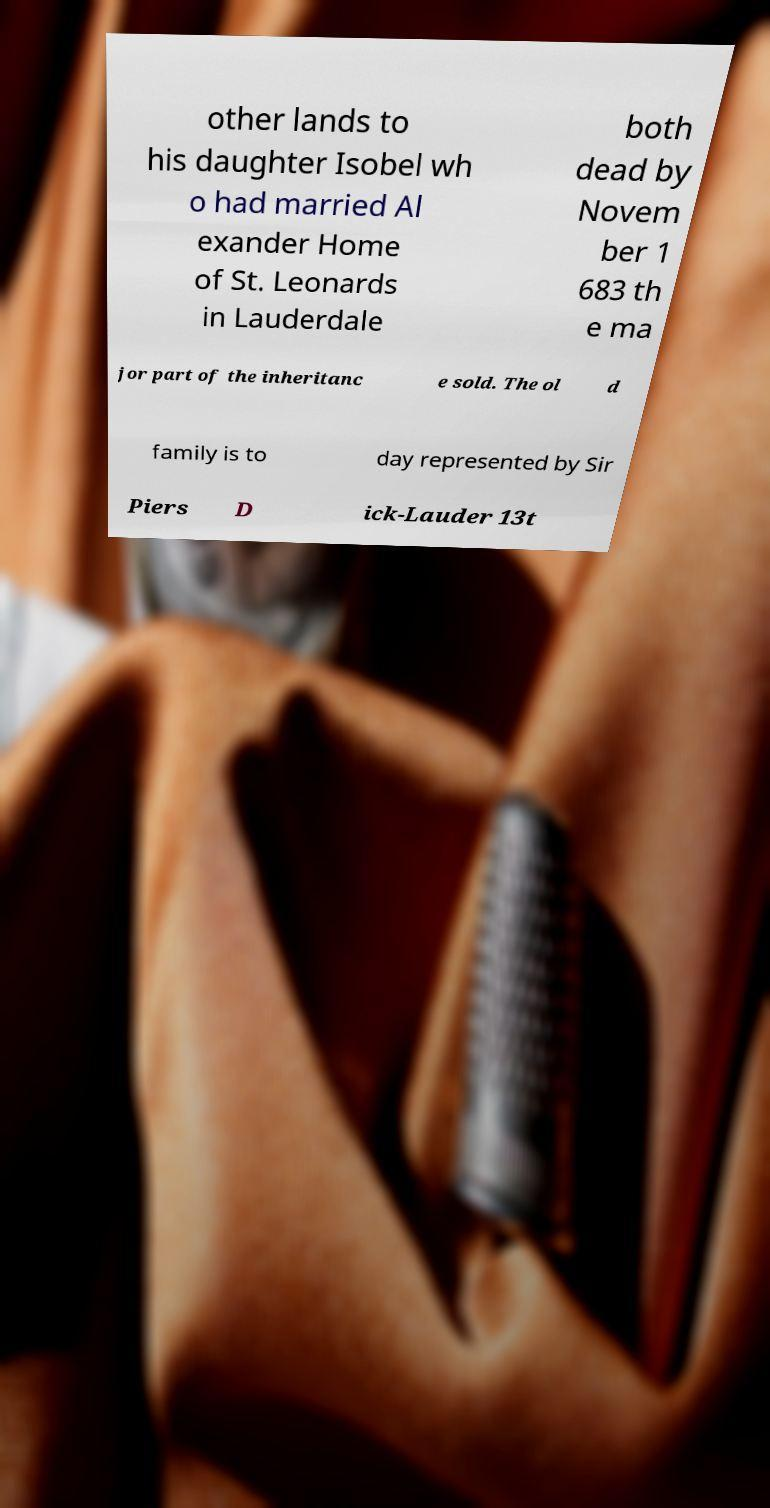Please read and relay the text visible in this image. What does it say? other lands to his daughter Isobel wh o had married Al exander Home of St. Leonards in Lauderdale both dead by Novem ber 1 683 th e ma jor part of the inheritanc e sold. The ol d family is to day represented by Sir Piers D ick-Lauder 13t 